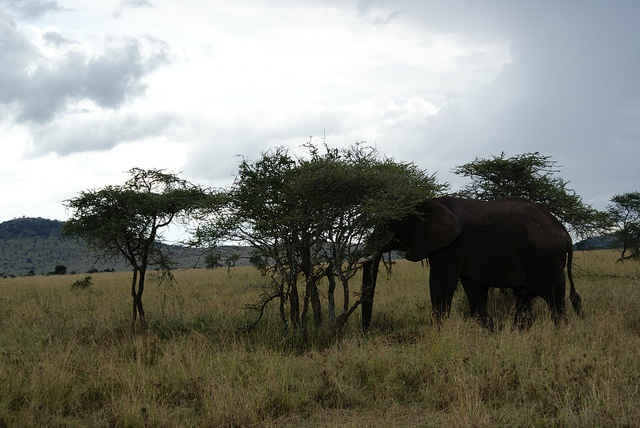Describe the objects in this image and their specific colors. I can see a elephant in lightgray, black, darkgreen, and gray tones in this image. 